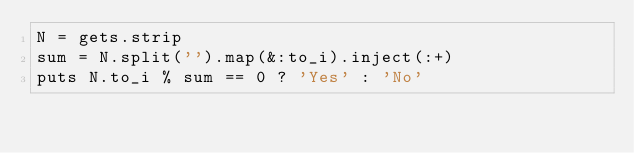Convert code to text. <code><loc_0><loc_0><loc_500><loc_500><_Ruby_>N = gets.strip
sum = N.split('').map(&:to_i).inject(:+)
puts N.to_i % sum == 0 ? 'Yes' : 'No'
</code> 